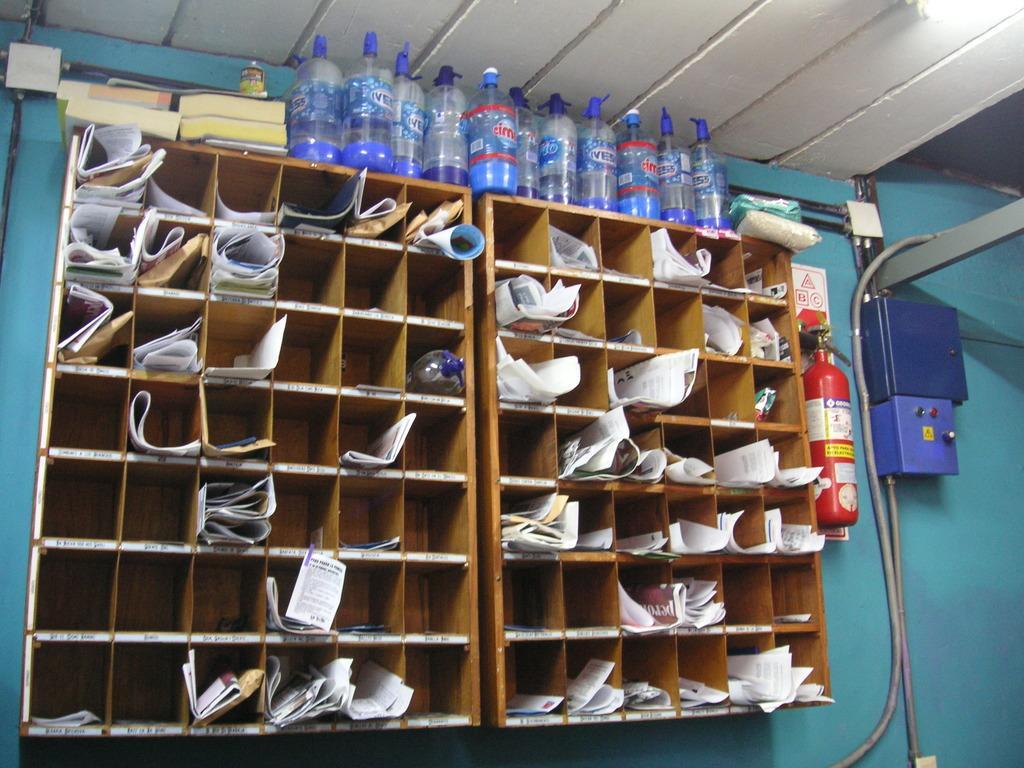Could you give a brief overview of what you see in this image? In this given picture, We can see a roof which is in white color towards the right, We can see few electrical boxes which are fixed to the wall next, we can see the fire extinguisher finally, We can see two cupboards filled with documents, water bottle and we can see electrical wires, a couple of water bottles placed on top of cupboards and a wall in blue color. 